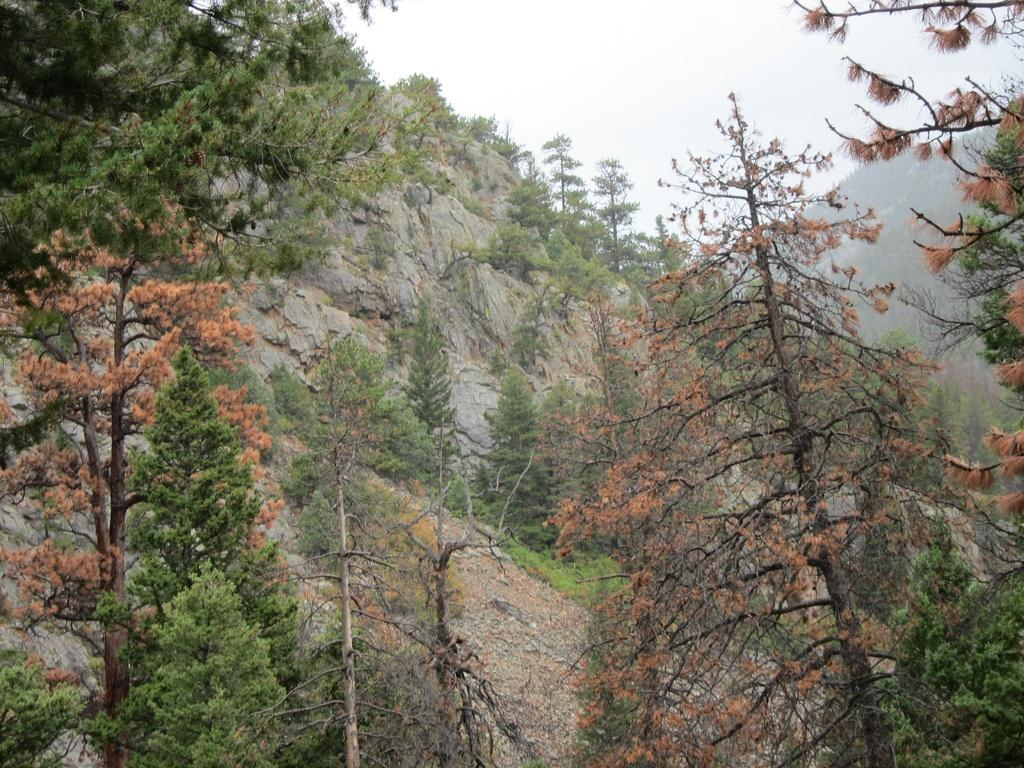What type of landscape can be seen in the image? There are hills in the image. What type of vegetation is present in the image? There are trees in the image. What is visible in the sky in the image? There are clouds in the sky. What type of nail is being used to hang the verse on the tree in the image? There is no nail or verse present in the image; it only features hills, trees, and clouds. 